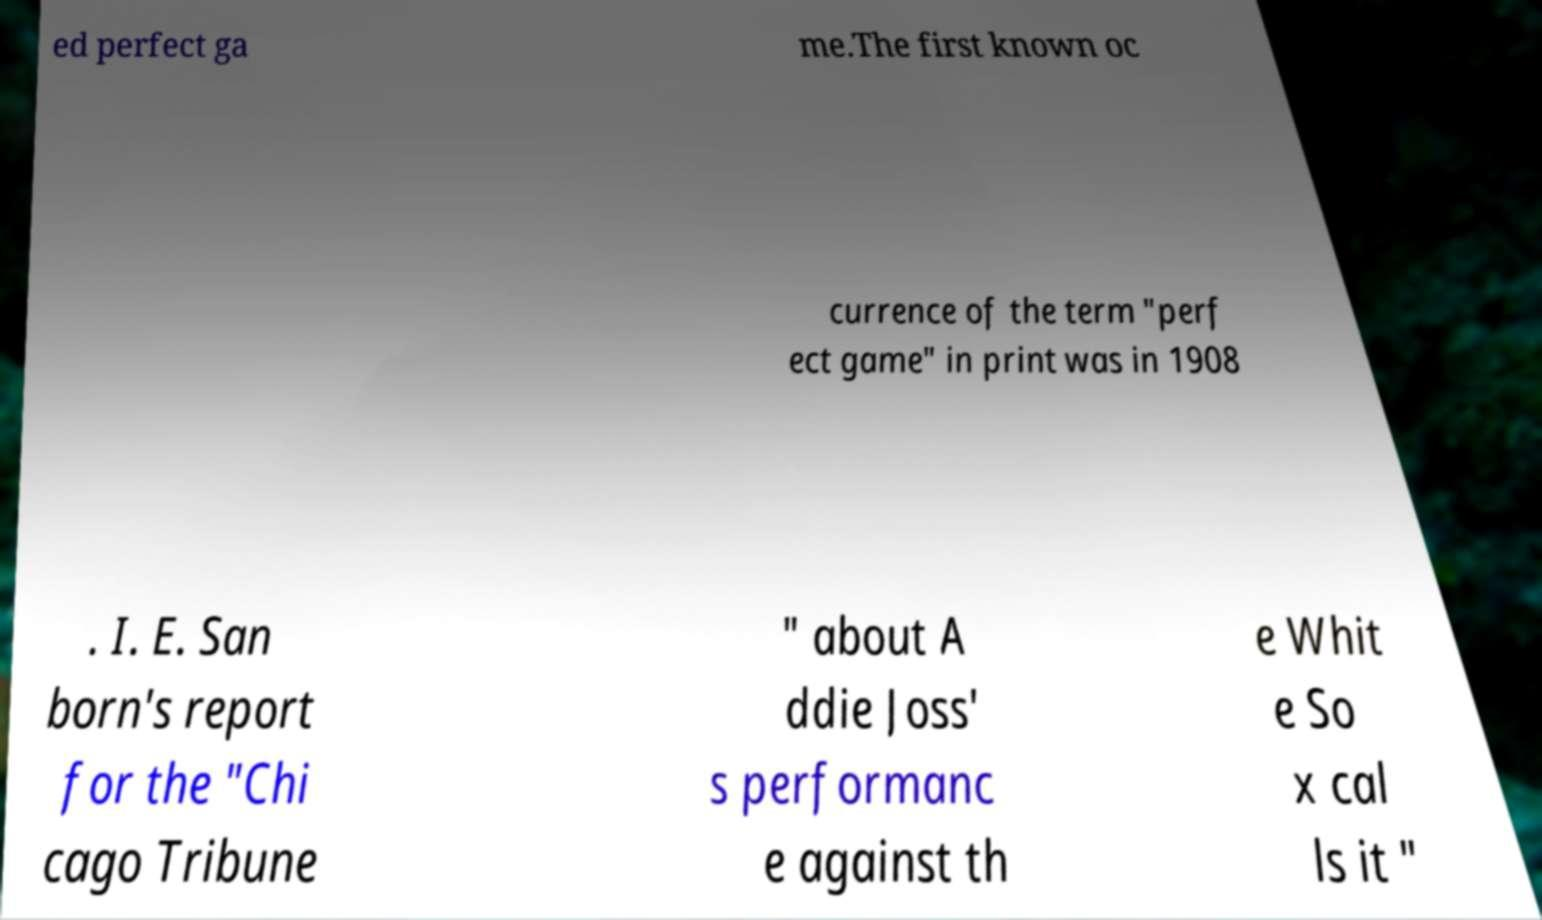Could you extract and type out the text from this image? ed perfect ga me.The first known oc currence of the term "perf ect game" in print was in 1908 . I. E. San born's report for the "Chi cago Tribune " about A ddie Joss' s performanc e against th e Whit e So x cal ls it " 